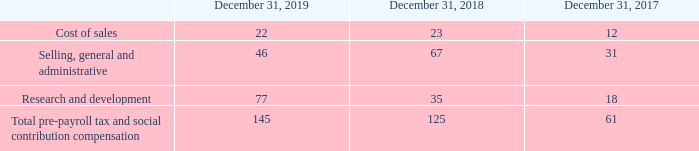The following table illustrates the classification of pre-payroll tax and social contribution stock-based compensation expense included in the consolidated statements of income for the years ended December 31, 2019, December 31, 2018 and December 31, 2017:
The fair value of the shares vested in 2019 was $114 million compared to $68 million for 2018 and $38 million for 2017.
Compensation cost, excluding payroll tax and social contribution, capitalized as part of inventory was $6 million as of December 31, 2019, compared to $6 million as of December 31, 2018 and $3 million as of December 31, 2017. As of December 31, 2019, there was $138 million of total unrecognized compensation cost related to the grant of unvested shares, which is expected to be recognized over a weighted average period of approximately 9 months.
The total deferred income tax benefit recognized in the consolidated statements of income related to unvested share-based compensation expense amounted to $9 million, $7 million and $3 million for the years ended December 31, 2019, 2018 and 2017, respectively.
What was the fair value of the shares vested in 2019? $114 million. What was the compensation cost excluding payroll tax and social contribution, capitalised as a part of inventory as of 31 December 2019? $6 million. What was the total deferred income tax benefit recognized in 019? $9 million. What was the increase ./ (decrease) in the cost of sales from 2018 to 2019?
Answer scale should be: million. 22 - 23
Answer: -1. What was the average of Selling, general and administrative?
Answer scale should be: million. (46 + 67 + 31) / 3
Answer: 48. What was the percentage increase / (decrease) in the Research and development from 2018 to 2019?
Answer scale should be: percent. 77 / 35 - 1
Answer: 120. 